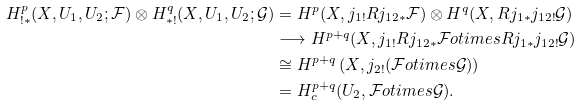<formula> <loc_0><loc_0><loc_500><loc_500>H ^ { p } _ { ! * } ( X , U _ { 1 } , U _ { 2 } ; \mathcal { F } ) \otimes H ^ { q } _ { * ! } ( X , U _ { 1 } , U _ { 2 } ; \mathcal { G } ) & = H ^ { p } ( X , j _ { 1 ! } R j _ { 1 2 * } \mathcal { F } ) \otimes H ^ { q } ( X , R j _ { 1 * } j _ { 1 2 ! } \mathcal { G } ) \\ & \longrightarrow H ^ { p + q } ( X , j _ { 1 ! } R j _ { 1 2 * } \mathcal { F } \L o t i m e s R j _ { 1 * } j _ { 1 2 ! } \mathcal { G } ) \\ & \cong H ^ { p + q } \left ( X , j _ { 2 ! } ( \mathcal { F } \L o t i m e s \mathcal { G } ) \right ) \\ & = H ^ { p + q } _ { c } ( U _ { 2 } , \mathcal { F } \L o t i m e s \mathcal { G } ) .</formula> 